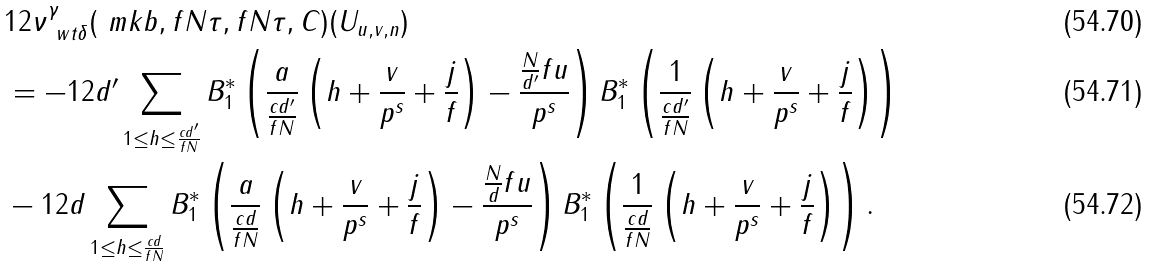Convert formula to latex. <formula><loc_0><loc_0><loc_500><loc_500>& 1 2 \nu _ { \ w t { \delta } } ^ { \gamma } ( \ m k { b } , f N \tau , f N \tau , C ) ( U _ { u , v , n } ) \\ & = - 1 2 d ^ { \prime } \sum _ { \substack { 1 \leq h \leq \frac { c d ^ { \prime } } { f N } } } B _ { 1 } ^ { * } \left ( \frac { a } { \frac { c d ^ { \prime } } { f N } } \left ( h + \frac { v } { p ^ { s } } + \frac { j } { f } \right ) - \frac { \frac { N } { d ^ { \prime } } f u } { p ^ { s } } \right ) B _ { 1 } ^ { * } \left ( \frac { 1 } { \frac { c d ^ { \prime } } { f N } } \left ( h + \frac { v } { p ^ { s } } + \frac { j } { f } \right ) \right ) \\ & - 1 2 d \sum _ { \substack { 1 \leq h \leq \frac { c d } { f N } } } B _ { 1 } ^ { * } \left ( \frac { a } { \frac { c d } { f N } } \left ( h + \frac { v } { p ^ { s } } + \frac { j } { f } \right ) - \frac { \frac { N } { d } f u } { p ^ { s } } \right ) B _ { 1 } ^ { * } \left ( \frac { 1 } { \frac { c d } { f N } } \left ( h + \frac { v } { p ^ { s } } + \frac { j } { f } \right ) \right ) .</formula> 